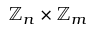<formula> <loc_0><loc_0><loc_500><loc_500>\mathbb { Z } _ { n } \times \mathbb { Z } _ { m }</formula> 